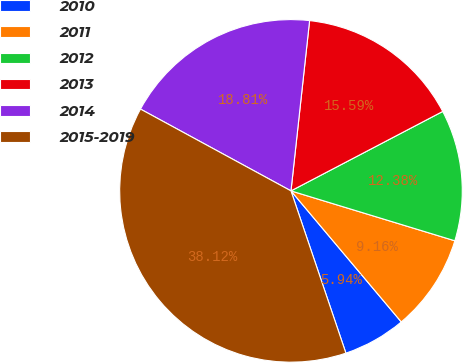<chart> <loc_0><loc_0><loc_500><loc_500><pie_chart><fcel>2010<fcel>2011<fcel>2012<fcel>2013<fcel>2014<fcel>2015-2019<nl><fcel>5.94%<fcel>9.16%<fcel>12.38%<fcel>15.59%<fcel>18.81%<fcel>38.12%<nl></chart> 